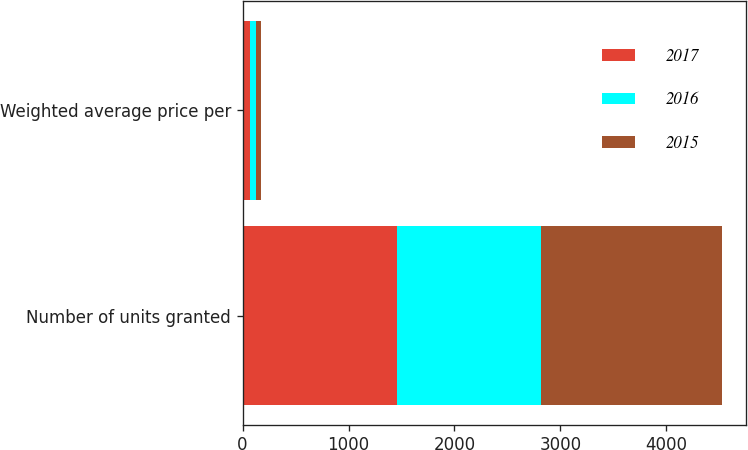Convert chart. <chart><loc_0><loc_0><loc_500><loc_500><stacked_bar_chart><ecel><fcel>Number of units granted<fcel>Weighted average price per<nl><fcel>2017<fcel>1462.3<fcel>67.01<nl><fcel>2016<fcel>1351.5<fcel>56<nl><fcel>2015<fcel>1708.2<fcel>53.45<nl></chart> 